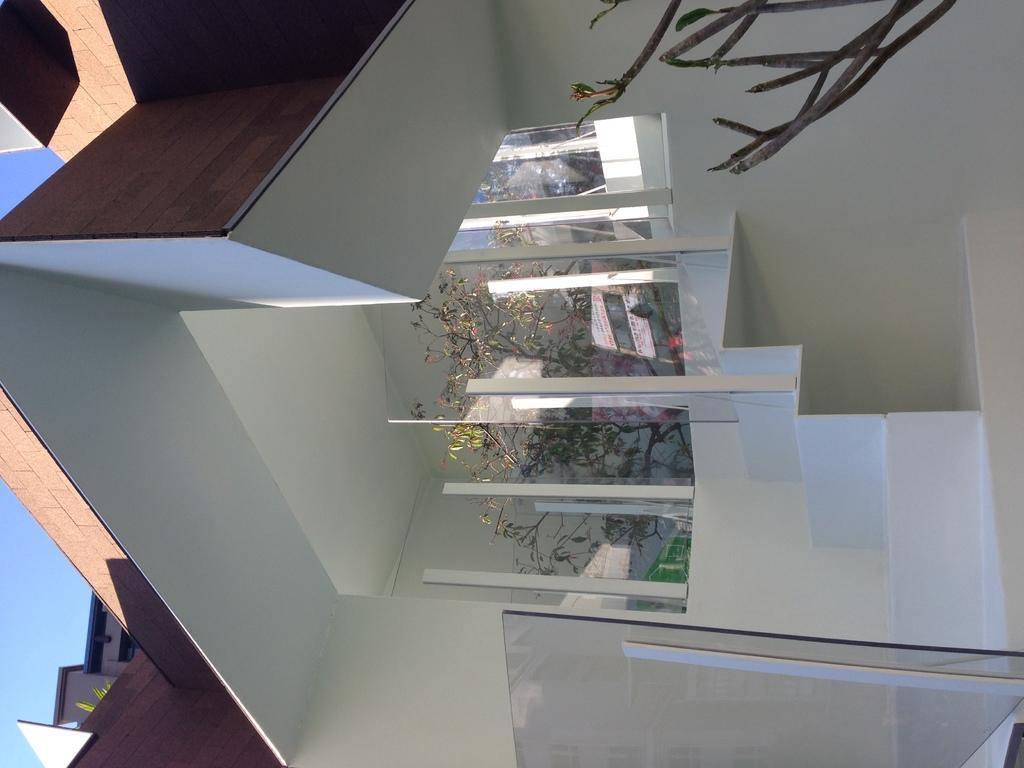Describe this image in one or two sentences. In this image we can see the porch of a building there are trees in the porch. 